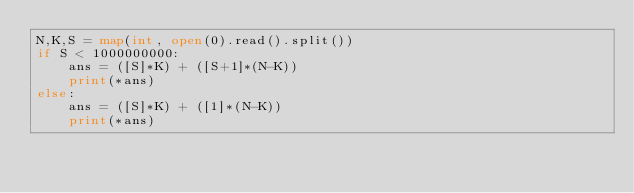<code> <loc_0><loc_0><loc_500><loc_500><_Python_>N,K,S = map(int, open(0).read().split())
if S < 1000000000:
    ans = ([S]*K) + ([S+1]*(N-K))
    print(*ans)
else:
    ans = ([S]*K) + ([1]*(N-K))
    print(*ans)</code> 